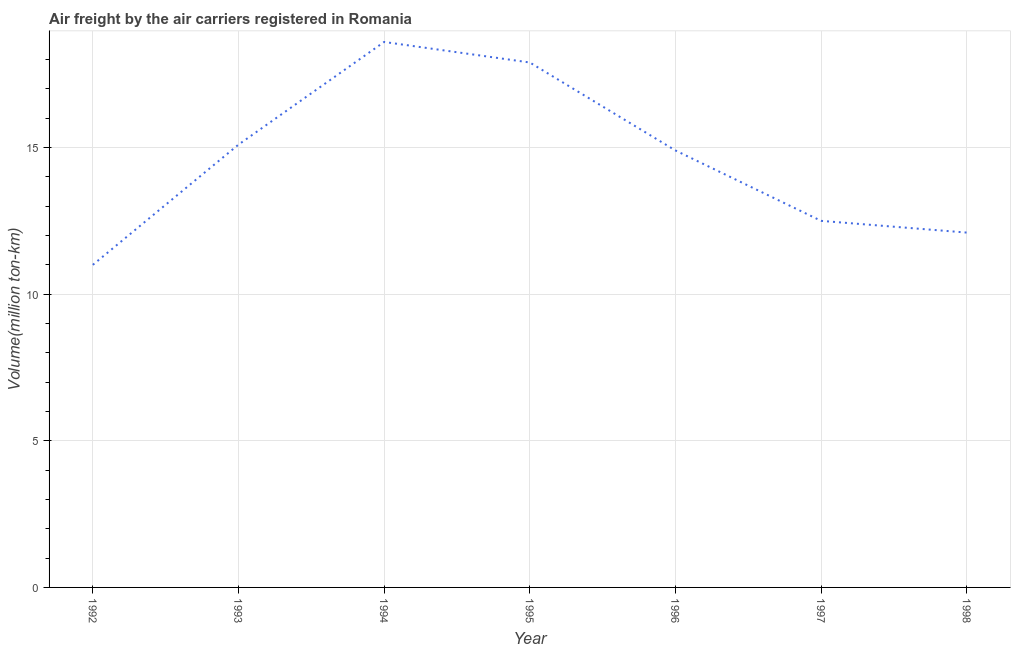What is the air freight in 1998?
Your answer should be compact. 12.1. Across all years, what is the maximum air freight?
Ensure brevity in your answer.  18.6. Across all years, what is the minimum air freight?
Your answer should be very brief. 11. In which year was the air freight maximum?
Give a very brief answer. 1994. In which year was the air freight minimum?
Your answer should be very brief. 1992. What is the sum of the air freight?
Your answer should be compact. 102.1. What is the average air freight per year?
Ensure brevity in your answer.  14.59. What is the median air freight?
Your answer should be compact. 14.9. What is the ratio of the air freight in 1993 to that in 1997?
Ensure brevity in your answer.  1.21. Is the air freight in 1992 less than that in 1996?
Provide a short and direct response. Yes. Is the difference between the air freight in 1995 and 1998 greater than the difference between any two years?
Your answer should be very brief. No. What is the difference between the highest and the second highest air freight?
Provide a short and direct response. 0.7. What is the difference between the highest and the lowest air freight?
Offer a very short reply. 7.6. How many lines are there?
Offer a very short reply. 1. Does the graph contain grids?
Your answer should be very brief. Yes. What is the title of the graph?
Your response must be concise. Air freight by the air carriers registered in Romania. What is the label or title of the X-axis?
Your answer should be compact. Year. What is the label or title of the Y-axis?
Your answer should be very brief. Volume(million ton-km). What is the Volume(million ton-km) in 1992?
Make the answer very short. 11. What is the Volume(million ton-km) in 1993?
Offer a terse response. 15.1. What is the Volume(million ton-km) of 1994?
Your answer should be compact. 18.6. What is the Volume(million ton-km) of 1995?
Provide a short and direct response. 17.9. What is the Volume(million ton-km) in 1996?
Provide a succinct answer. 14.9. What is the Volume(million ton-km) in 1997?
Offer a terse response. 12.5. What is the Volume(million ton-km) of 1998?
Make the answer very short. 12.1. What is the difference between the Volume(million ton-km) in 1992 and 1993?
Your answer should be very brief. -4.1. What is the difference between the Volume(million ton-km) in 1992 and 1995?
Give a very brief answer. -6.9. What is the difference between the Volume(million ton-km) in 1992 and 1997?
Give a very brief answer. -1.5. What is the difference between the Volume(million ton-km) in 1993 and 1995?
Your answer should be compact. -2.8. What is the difference between the Volume(million ton-km) in 1993 and 1996?
Your answer should be compact. 0.2. What is the difference between the Volume(million ton-km) in 1993 and 1998?
Ensure brevity in your answer.  3. What is the difference between the Volume(million ton-km) in 1994 and 1995?
Provide a short and direct response. 0.7. What is the difference between the Volume(million ton-km) in 1994 and 1996?
Offer a terse response. 3.7. What is the difference between the Volume(million ton-km) in 1994 and 1998?
Offer a terse response. 6.5. What is the difference between the Volume(million ton-km) in 1996 and 1998?
Provide a short and direct response. 2.8. What is the difference between the Volume(million ton-km) in 1997 and 1998?
Your response must be concise. 0.4. What is the ratio of the Volume(million ton-km) in 1992 to that in 1993?
Provide a succinct answer. 0.73. What is the ratio of the Volume(million ton-km) in 1992 to that in 1994?
Provide a short and direct response. 0.59. What is the ratio of the Volume(million ton-km) in 1992 to that in 1995?
Make the answer very short. 0.61. What is the ratio of the Volume(million ton-km) in 1992 to that in 1996?
Provide a succinct answer. 0.74. What is the ratio of the Volume(million ton-km) in 1992 to that in 1998?
Offer a terse response. 0.91. What is the ratio of the Volume(million ton-km) in 1993 to that in 1994?
Provide a short and direct response. 0.81. What is the ratio of the Volume(million ton-km) in 1993 to that in 1995?
Provide a short and direct response. 0.84. What is the ratio of the Volume(million ton-km) in 1993 to that in 1997?
Offer a very short reply. 1.21. What is the ratio of the Volume(million ton-km) in 1993 to that in 1998?
Ensure brevity in your answer.  1.25. What is the ratio of the Volume(million ton-km) in 1994 to that in 1995?
Provide a succinct answer. 1.04. What is the ratio of the Volume(million ton-km) in 1994 to that in 1996?
Give a very brief answer. 1.25. What is the ratio of the Volume(million ton-km) in 1994 to that in 1997?
Give a very brief answer. 1.49. What is the ratio of the Volume(million ton-km) in 1994 to that in 1998?
Offer a very short reply. 1.54. What is the ratio of the Volume(million ton-km) in 1995 to that in 1996?
Your answer should be compact. 1.2. What is the ratio of the Volume(million ton-km) in 1995 to that in 1997?
Your answer should be very brief. 1.43. What is the ratio of the Volume(million ton-km) in 1995 to that in 1998?
Your response must be concise. 1.48. What is the ratio of the Volume(million ton-km) in 1996 to that in 1997?
Keep it short and to the point. 1.19. What is the ratio of the Volume(million ton-km) in 1996 to that in 1998?
Ensure brevity in your answer.  1.23. What is the ratio of the Volume(million ton-km) in 1997 to that in 1998?
Your response must be concise. 1.03. 